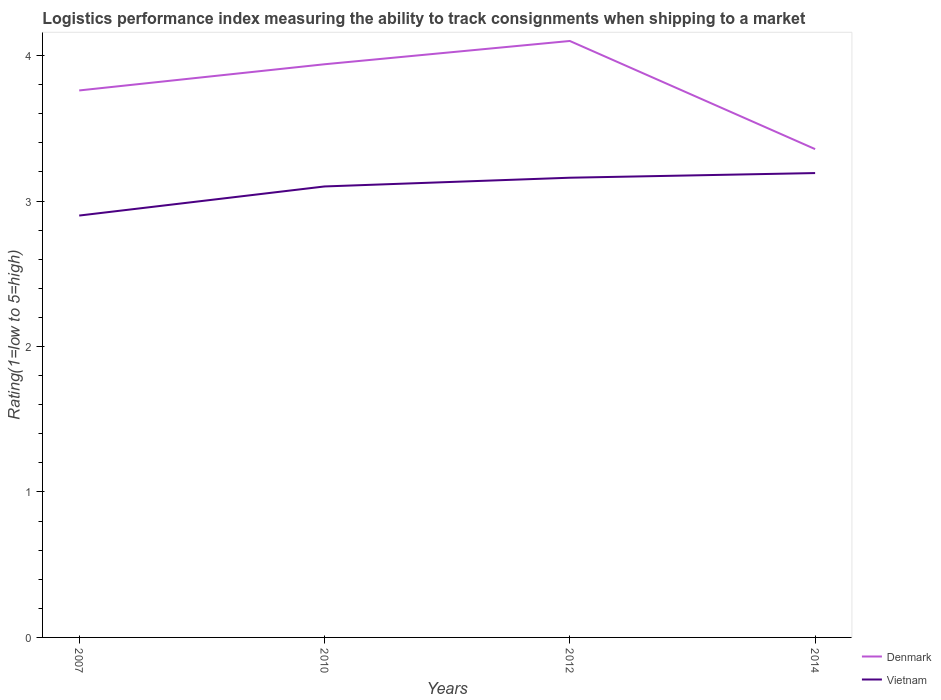How many different coloured lines are there?
Offer a very short reply. 2. Is the number of lines equal to the number of legend labels?
Your answer should be very brief. Yes. Across all years, what is the maximum Logistic performance index in Denmark?
Your answer should be compact. 3.36. What is the total Logistic performance index in Denmark in the graph?
Provide a succinct answer. -0.16. What is the difference between the highest and the second highest Logistic performance index in Denmark?
Offer a very short reply. 0.74. Is the Logistic performance index in Denmark strictly greater than the Logistic performance index in Vietnam over the years?
Give a very brief answer. No. How many years are there in the graph?
Your answer should be compact. 4. What is the difference between two consecutive major ticks on the Y-axis?
Your response must be concise. 1. How are the legend labels stacked?
Make the answer very short. Vertical. What is the title of the graph?
Ensure brevity in your answer.  Logistics performance index measuring the ability to track consignments when shipping to a market. What is the label or title of the X-axis?
Your response must be concise. Years. What is the label or title of the Y-axis?
Ensure brevity in your answer.  Rating(1=low to 5=high). What is the Rating(1=low to 5=high) of Denmark in 2007?
Your answer should be very brief. 3.76. What is the Rating(1=low to 5=high) of Denmark in 2010?
Your answer should be very brief. 3.94. What is the Rating(1=low to 5=high) of Vietnam in 2010?
Offer a very short reply. 3.1. What is the Rating(1=low to 5=high) of Denmark in 2012?
Ensure brevity in your answer.  4.1. What is the Rating(1=low to 5=high) in Vietnam in 2012?
Your answer should be very brief. 3.16. What is the Rating(1=low to 5=high) of Denmark in 2014?
Keep it short and to the point. 3.36. What is the Rating(1=low to 5=high) of Vietnam in 2014?
Provide a succinct answer. 3.19. Across all years, what is the maximum Rating(1=low to 5=high) in Vietnam?
Make the answer very short. 3.19. Across all years, what is the minimum Rating(1=low to 5=high) in Denmark?
Make the answer very short. 3.36. What is the total Rating(1=low to 5=high) in Denmark in the graph?
Keep it short and to the point. 15.16. What is the total Rating(1=low to 5=high) of Vietnam in the graph?
Offer a very short reply. 12.35. What is the difference between the Rating(1=low to 5=high) of Denmark in 2007 and that in 2010?
Make the answer very short. -0.18. What is the difference between the Rating(1=low to 5=high) in Denmark in 2007 and that in 2012?
Provide a short and direct response. -0.34. What is the difference between the Rating(1=low to 5=high) in Vietnam in 2007 and that in 2012?
Provide a short and direct response. -0.26. What is the difference between the Rating(1=low to 5=high) of Denmark in 2007 and that in 2014?
Your answer should be compact. 0.4. What is the difference between the Rating(1=low to 5=high) of Vietnam in 2007 and that in 2014?
Provide a short and direct response. -0.29. What is the difference between the Rating(1=low to 5=high) of Denmark in 2010 and that in 2012?
Offer a very short reply. -0.16. What is the difference between the Rating(1=low to 5=high) in Vietnam in 2010 and that in 2012?
Make the answer very short. -0.06. What is the difference between the Rating(1=low to 5=high) of Denmark in 2010 and that in 2014?
Your response must be concise. 0.58. What is the difference between the Rating(1=low to 5=high) in Vietnam in 2010 and that in 2014?
Ensure brevity in your answer.  -0.09. What is the difference between the Rating(1=low to 5=high) in Denmark in 2012 and that in 2014?
Offer a very short reply. 0.74. What is the difference between the Rating(1=low to 5=high) of Vietnam in 2012 and that in 2014?
Offer a terse response. -0.03. What is the difference between the Rating(1=low to 5=high) of Denmark in 2007 and the Rating(1=low to 5=high) of Vietnam in 2010?
Your response must be concise. 0.66. What is the difference between the Rating(1=low to 5=high) of Denmark in 2007 and the Rating(1=low to 5=high) of Vietnam in 2012?
Provide a succinct answer. 0.6. What is the difference between the Rating(1=low to 5=high) of Denmark in 2007 and the Rating(1=low to 5=high) of Vietnam in 2014?
Your answer should be very brief. 0.57. What is the difference between the Rating(1=low to 5=high) of Denmark in 2010 and the Rating(1=low to 5=high) of Vietnam in 2012?
Keep it short and to the point. 0.78. What is the difference between the Rating(1=low to 5=high) of Denmark in 2010 and the Rating(1=low to 5=high) of Vietnam in 2014?
Your answer should be compact. 0.75. What is the difference between the Rating(1=low to 5=high) of Denmark in 2012 and the Rating(1=low to 5=high) of Vietnam in 2014?
Your answer should be compact. 0.91. What is the average Rating(1=low to 5=high) in Denmark per year?
Provide a short and direct response. 3.79. What is the average Rating(1=low to 5=high) of Vietnam per year?
Your response must be concise. 3.09. In the year 2007, what is the difference between the Rating(1=low to 5=high) in Denmark and Rating(1=low to 5=high) in Vietnam?
Offer a terse response. 0.86. In the year 2010, what is the difference between the Rating(1=low to 5=high) of Denmark and Rating(1=low to 5=high) of Vietnam?
Ensure brevity in your answer.  0.84. In the year 2014, what is the difference between the Rating(1=low to 5=high) in Denmark and Rating(1=low to 5=high) in Vietnam?
Provide a succinct answer. 0.16. What is the ratio of the Rating(1=low to 5=high) in Denmark in 2007 to that in 2010?
Give a very brief answer. 0.95. What is the ratio of the Rating(1=low to 5=high) of Vietnam in 2007 to that in 2010?
Your answer should be compact. 0.94. What is the ratio of the Rating(1=low to 5=high) in Denmark in 2007 to that in 2012?
Make the answer very short. 0.92. What is the ratio of the Rating(1=low to 5=high) in Vietnam in 2007 to that in 2012?
Give a very brief answer. 0.92. What is the ratio of the Rating(1=low to 5=high) of Denmark in 2007 to that in 2014?
Provide a short and direct response. 1.12. What is the ratio of the Rating(1=low to 5=high) of Vietnam in 2007 to that in 2014?
Give a very brief answer. 0.91. What is the ratio of the Rating(1=low to 5=high) of Vietnam in 2010 to that in 2012?
Provide a short and direct response. 0.98. What is the ratio of the Rating(1=low to 5=high) of Denmark in 2010 to that in 2014?
Make the answer very short. 1.17. What is the ratio of the Rating(1=low to 5=high) of Vietnam in 2010 to that in 2014?
Provide a short and direct response. 0.97. What is the ratio of the Rating(1=low to 5=high) of Denmark in 2012 to that in 2014?
Offer a terse response. 1.22. What is the difference between the highest and the second highest Rating(1=low to 5=high) of Denmark?
Provide a short and direct response. 0.16. What is the difference between the highest and the second highest Rating(1=low to 5=high) of Vietnam?
Your answer should be very brief. 0.03. What is the difference between the highest and the lowest Rating(1=low to 5=high) of Denmark?
Make the answer very short. 0.74. What is the difference between the highest and the lowest Rating(1=low to 5=high) in Vietnam?
Provide a succinct answer. 0.29. 